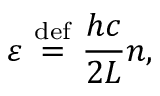<formula> <loc_0><loc_0><loc_500><loc_500>\varepsilon \ { \stackrel { d e f } { = } } \ { \frac { h c } { 2 L } } n ,</formula> 